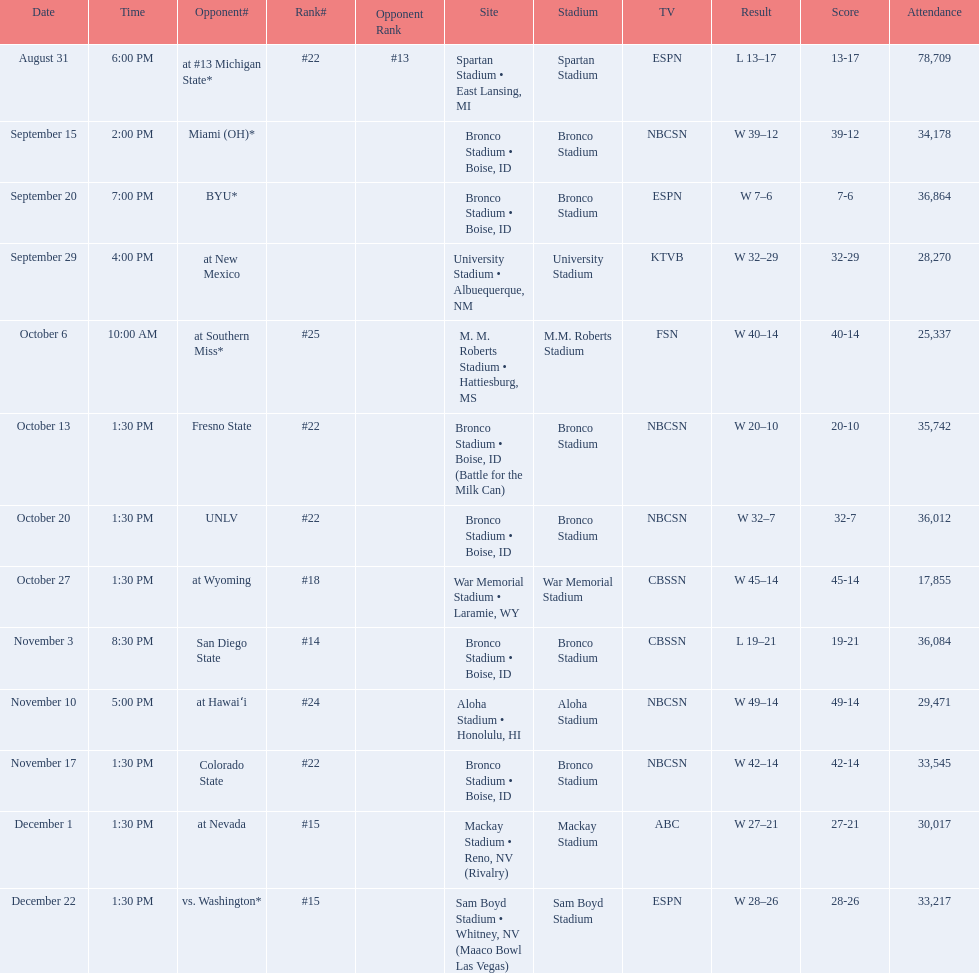Who were all the opponents for boise state? At #13 michigan state*, miami (oh)*, byu*, at new mexico, at southern miss*, fresno state, unlv, at wyoming, san diego state, at hawaiʻi, colorado state, at nevada, vs. washington*. Which opponents were ranked? At #13 michigan state*, #22, at southern miss*, #25, fresno state, #22, unlv, #22, at wyoming, #18, san diego state, #14. Which opponent had the highest rank? San Diego State. 